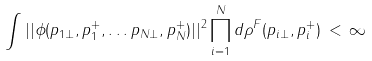<formula> <loc_0><loc_0><loc_500><loc_500>\int | | \phi ( { p } _ { 1 \bot } , p _ { 1 } ^ { + } , \dots { p } _ { N \bot } , p _ { N } ^ { + } ) | | ^ { 2 } \prod _ { i = 1 } ^ { N } d \rho ^ { F } ( { p } _ { i \bot } , p _ { i } ^ { + } ) \, < \, \infty</formula> 